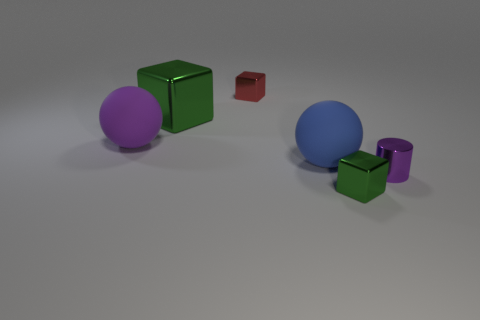What size is the other object that is the same shape as the big blue matte object?
Offer a terse response. Large. What is the shape of the purple metallic object?
Make the answer very short. Cylinder. Is the blue sphere made of the same material as the green cube behind the purple metal cylinder?
Your answer should be very brief. No. How many metallic things are either tiny blue cylinders or purple balls?
Provide a succinct answer. 0. There is a shiny block in front of the blue sphere; what size is it?
Your answer should be compact. Small. There is a purple cylinder that is the same material as the large green cube; what is its size?
Your answer should be compact. Small. What number of large cubes are the same color as the large shiny thing?
Your response must be concise. 0. Is there a blue thing?
Your answer should be compact. Yes. There is a small purple metallic thing; does it have the same shape as the object in front of the cylinder?
Offer a terse response. No. There is a big rubber ball to the left of the green metallic block that is behind the matte object left of the big green metal object; what is its color?
Your answer should be very brief. Purple. 